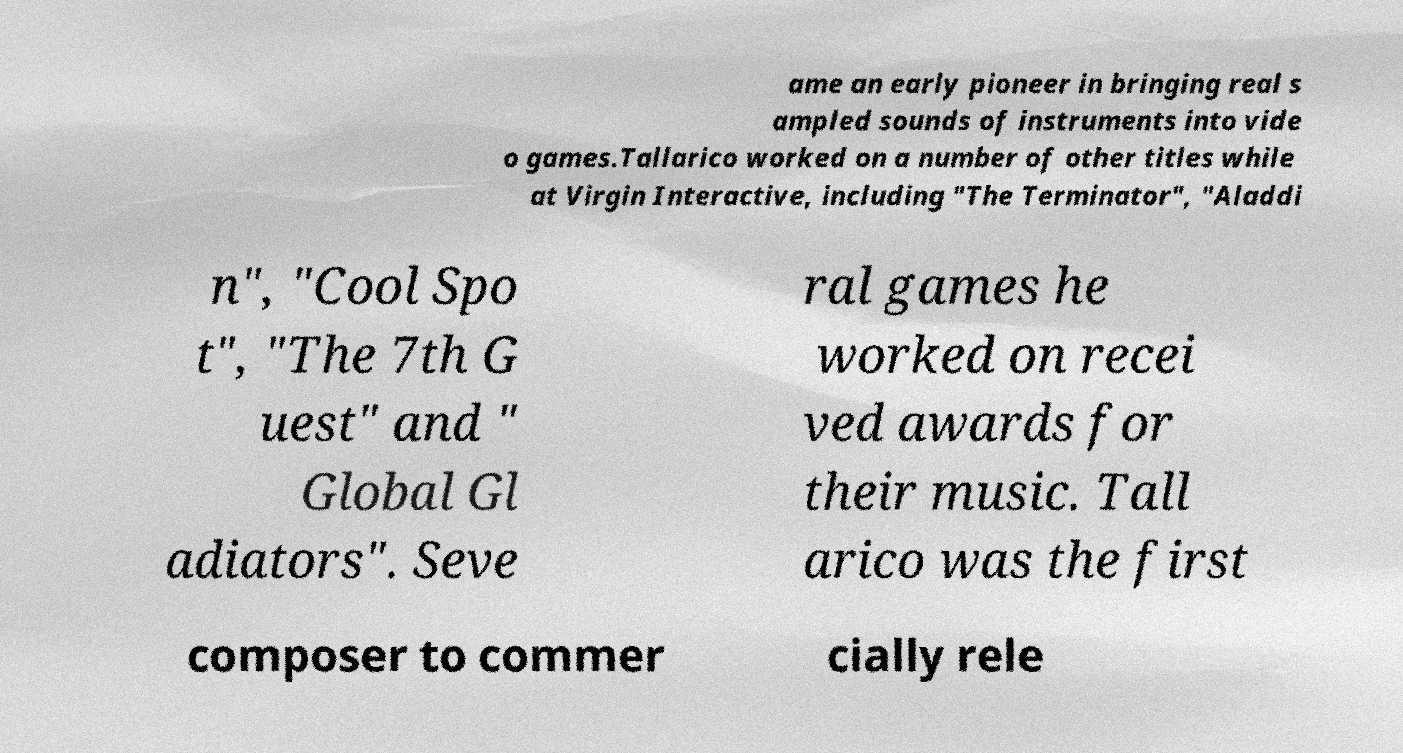Can you read and provide the text displayed in the image?This photo seems to have some interesting text. Can you extract and type it out for me? ame an early pioneer in bringing real s ampled sounds of instruments into vide o games.Tallarico worked on a number of other titles while at Virgin Interactive, including "The Terminator", "Aladdi n", "Cool Spo t", "The 7th G uest" and " Global Gl adiators". Seve ral games he worked on recei ved awards for their music. Tall arico was the first composer to commer cially rele 